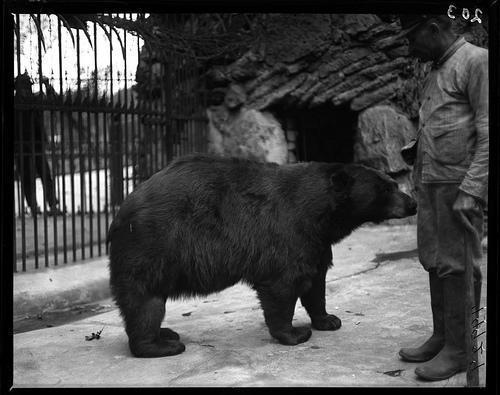How many people are in the photo?
Give a very brief answer. 2. 